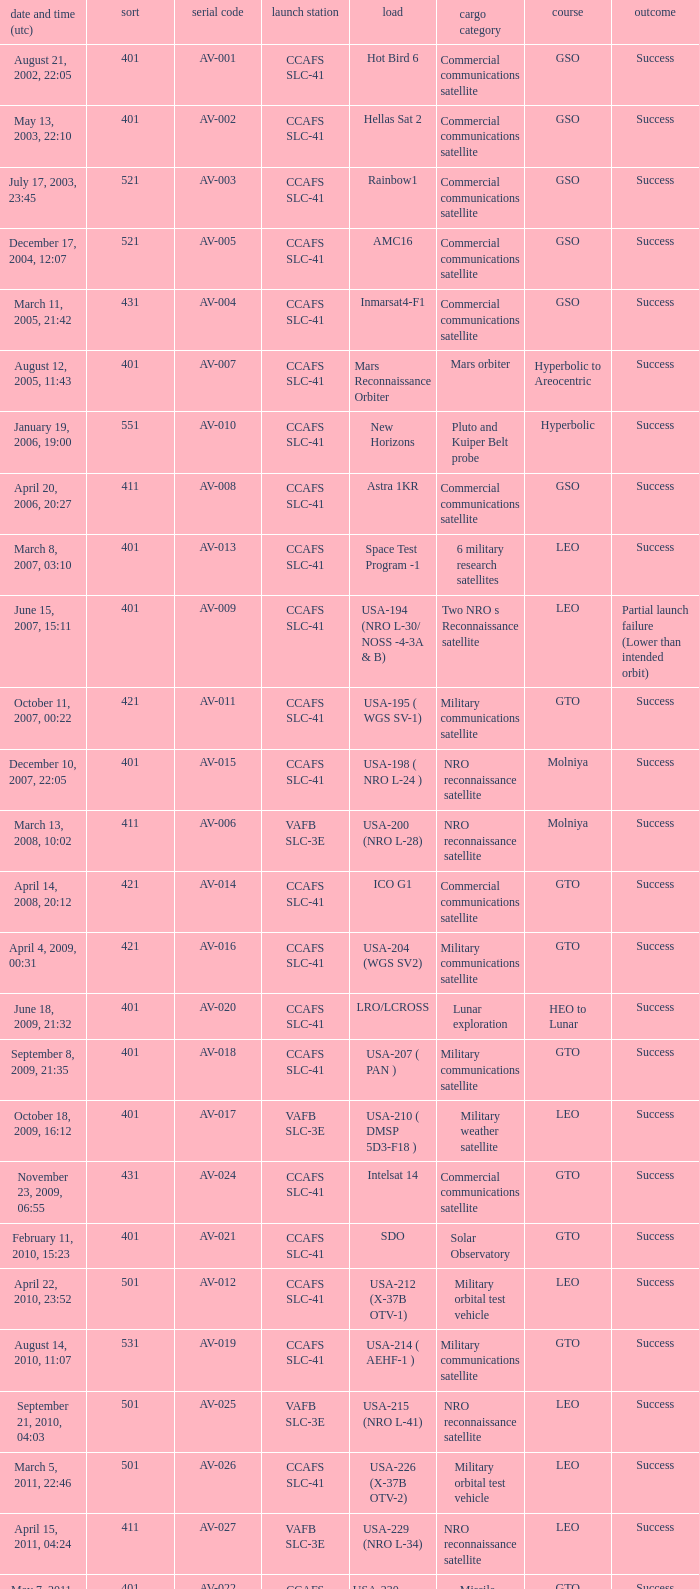For the payload of Van Allen Belts Exploration what's the serial number? AV-032. 